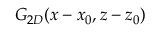Convert formula to latex. <formula><loc_0><loc_0><loc_500><loc_500>G _ { 2 D } ( x - x _ { 0 } , z - z _ { 0 } )</formula> 